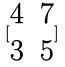Convert formula to latex. <formula><loc_0><loc_0><loc_500><loc_500>[ \begin{matrix} 4 & 7 \\ 3 & 5 \end{matrix} ]</formula> 